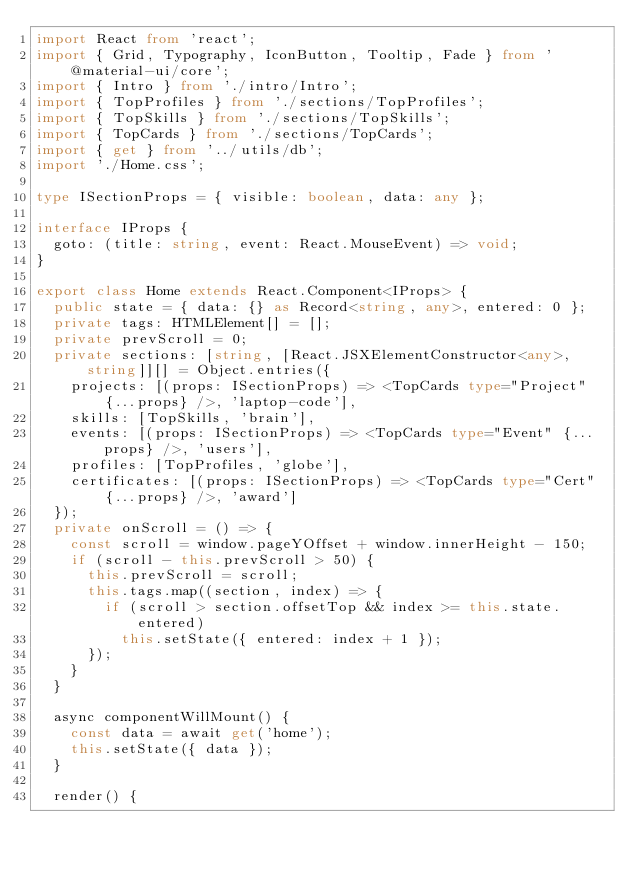Convert code to text. <code><loc_0><loc_0><loc_500><loc_500><_TypeScript_>import React from 'react';
import { Grid, Typography, IconButton, Tooltip, Fade } from '@material-ui/core';
import { Intro } from './intro/Intro';
import { TopProfiles } from './sections/TopProfiles';
import { TopSkills } from './sections/TopSkills';
import { TopCards } from './sections/TopCards';
import { get } from '../utils/db';
import './Home.css';

type ISectionProps = { visible: boolean, data: any };

interface IProps {
  goto: (title: string, event: React.MouseEvent) => void;
}

export class Home extends React.Component<IProps> {
  public state = { data: {} as Record<string, any>, entered: 0 };
  private tags: HTMLElement[] = [];
  private prevScroll = 0;
  private sections: [string, [React.JSXElementConstructor<any>, string]][] = Object.entries({
    projects: [(props: ISectionProps) => <TopCards type="Project" {...props} />, 'laptop-code'],
    skills: [TopSkills, 'brain'],
    events: [(props: ISectionProps) => <TopCards type="Event" {...props} />, 'users'],
    profiles: [TopProfiles, 'globe'],
    certificates: [(props: ISectionProps) => <TopCards type="Cert" {...props} />, 'award']
  });
  private onScroll = () => {
    const scroll = window.pageYOffset + window.innerHeight - 150;
    if (scroll - this.prevScroll > 50) {
      this.prevScroll = scroll;
      this.tags.map((section, index) => {
        if (scroll > section.offsetTop && index >= this.state.entered)
          this.setState({ entered: index + 1 });
      });
    }
  }

  async componentWillMount() {
    const data = await get('home');
    this.setState({ data });
  }

  render() {</code> 